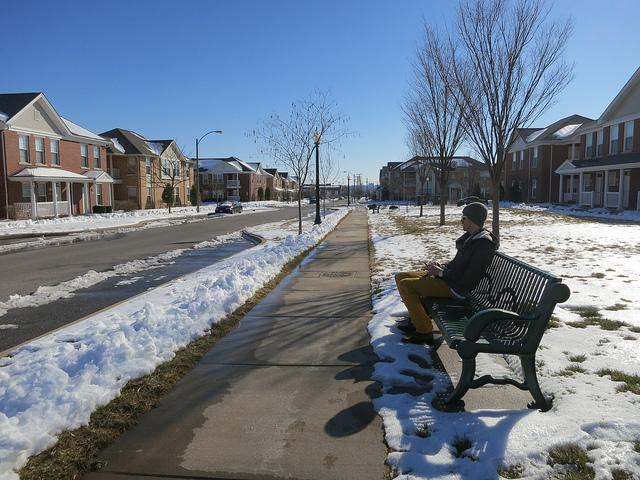In which area does the man wait? Please explain your reasoning. suburban. Looks to not be too busy of an area and more suburban. 